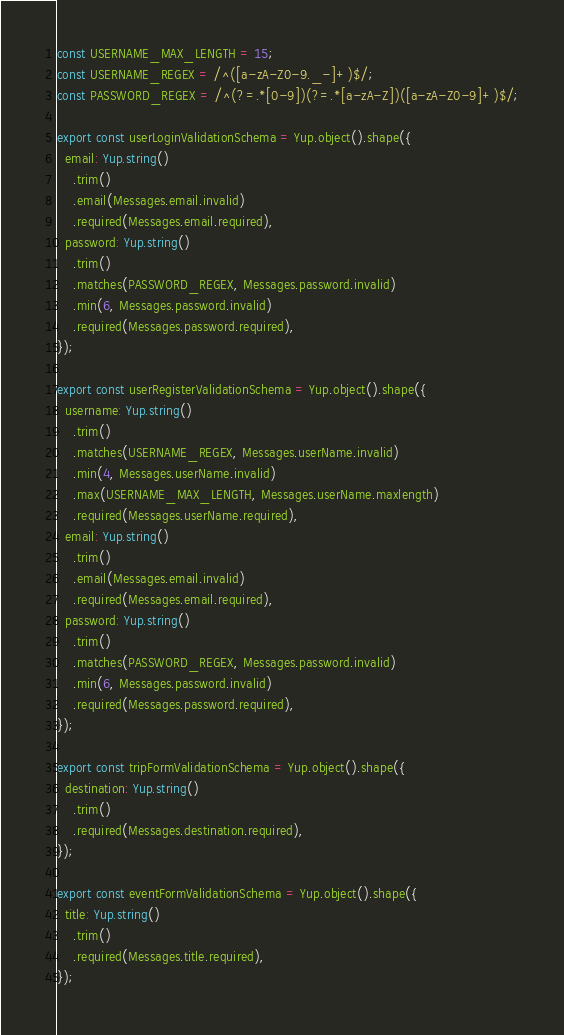Convert code to text. <code><loc_0><loc_0><loc_500><loc_500><_TypeScript_>
const USERNAME_MAX_LENGTH = 15;
const USERNAME_REGEX = /^([a-zA-Z0-9._-]+)$/;
const PASSWORD_REGEX = /^(?=.*[0-9])(?=.*[a-zA-Z])([a-zA-Z0-9]+)$/;

export const userLoginValidationSchema = Yup.object().shape({
  email: Yup.string()
    .trim()
    .email(Messages.email.invalid)
    .required(Messages.email.required),
  password: Yup.string()
    .trim()
    .matches(PASSWORD_REGEX, Messages.password.invalid)
    .min(6, Messages.password.invalid)
    .required(Messages.password.required),
});

export const userRegisterValidationSchema = Yup.object().shape({
  username: Yup.string()
    .trim()
    .matches(USERNAME_REGEX, Messages.userName.invalid)
    .min(4, Messages.userName.invalid)
    .max(USERNAME_MAX_LENGTH, Messages.userName.maxlength)
    .required(Messages.userName.required),
  email: Yup.string()
    .trim()
    .email(Messages.email.invalid)
    .required(Messages.email.required),
  password: Yup.string()
    .trim()
    .matches(PASSWORD_REGEX, Messages.password.invalid)
    .min(6, Messages.password.invalid)
    .required(Messages.password.required),
});

export const tripFormValidationSchema = Yup.object().shape({
  destination: Yup.string()
    .trim()
    .required(Messages.destination.required),
});

export const eventFormValidationSchema = Yup.object().shape({
  title: Yup.string()
    .trim()
    .required(Messages.title.required),
});
</code> 